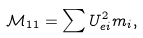<formula> <loc_0><loc_0><loc_500><loc_500>\mathcal { M } _ { 1 1 } = \sum U _ { e i } ^ { 2 } m _ { i } ,</formula> 